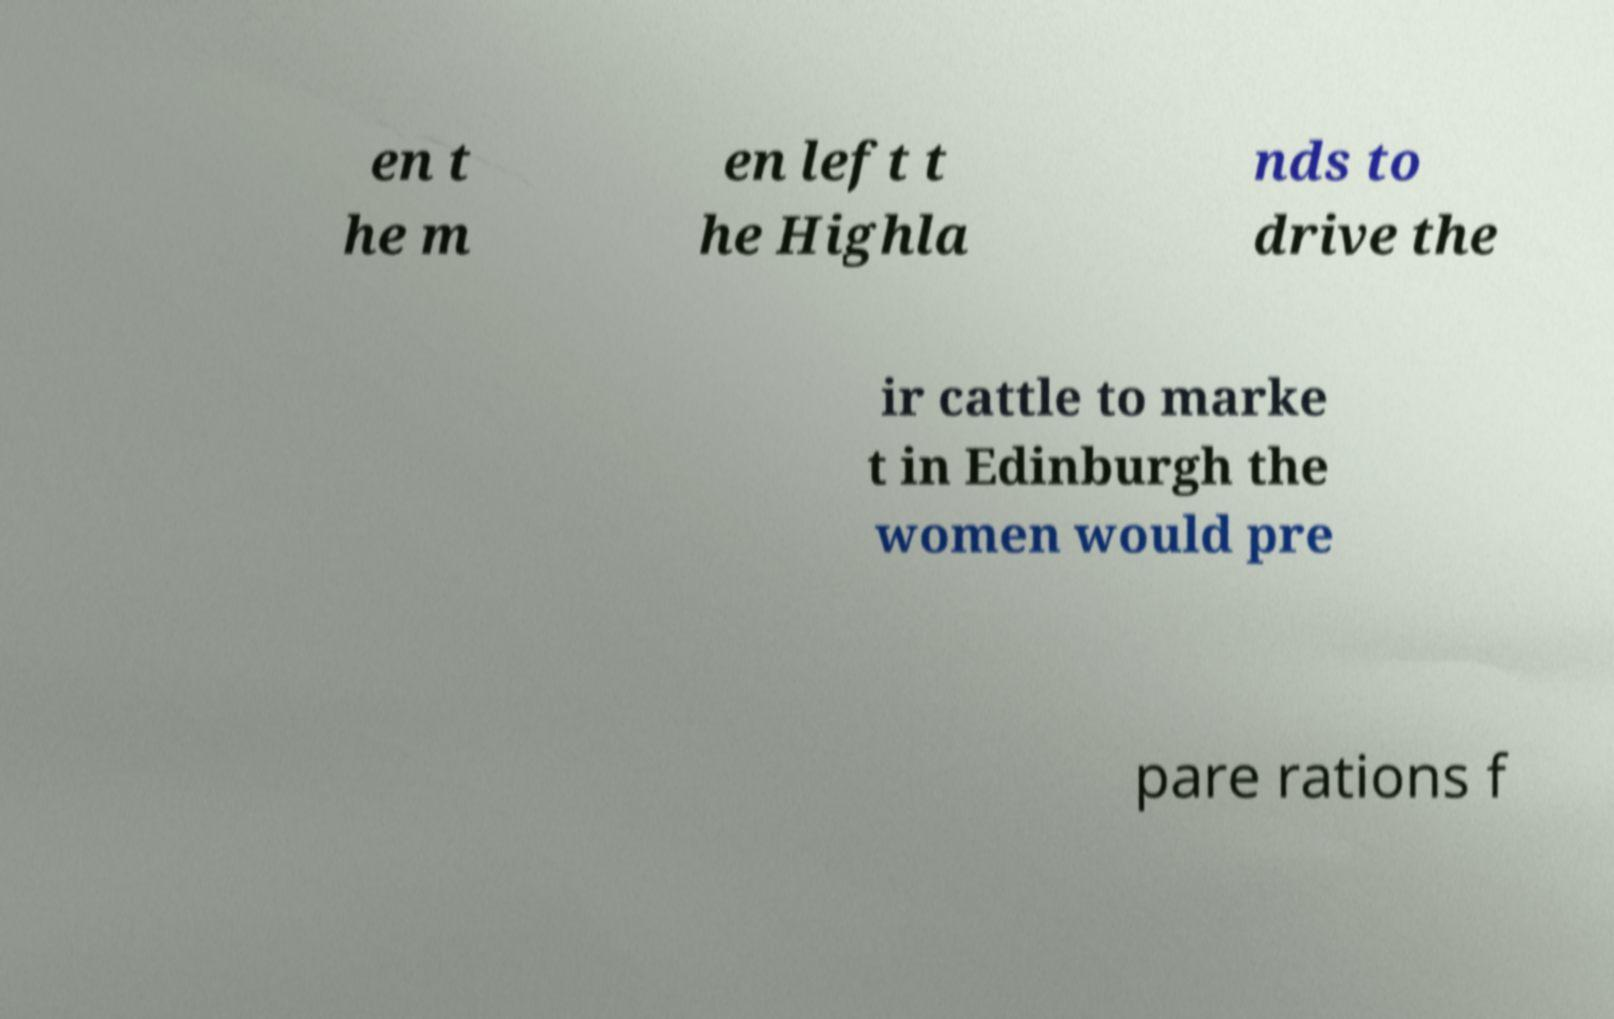Could you extract and type out the text from this image? en t he m en left t he Highla nds to drive the ir cattle to marke t in Edinburgh the women would pre pare rations f 